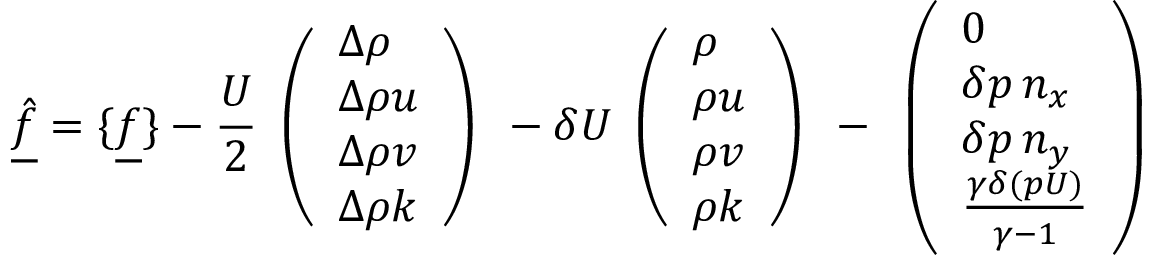<formula> <loc_0><loc_0><loc_500><loc_500>\underline { { \hat { f } } } = \{ \underline { f } \} - \frac { U } { 2 } \begin{array} { l } { \left ( \begin{array} { l } { \Delta \rho } \\ { \Delta \rho u } \\ { \Delta \rho v } \\ { \Delta \rho k } \end{array} \right ) } \end{array} - \delta U \begin{array} { l } { \left ( \begin{array} { l } { \rho } \\ { \rho u } \\ { \rho v } \\ { \rho k } \end{array} \right ) } \end{array} - \begin{array} { l } { \left ( \begin{array} { l } { 0 } \\ { \delta p \, n _ { x } } \\ { \delta p \, n _ { y } } \\ { \frac { \gamma \delta ( p U ) } { \gamma - 1 } } \end{array} \right ) } \end{array}</formula> 